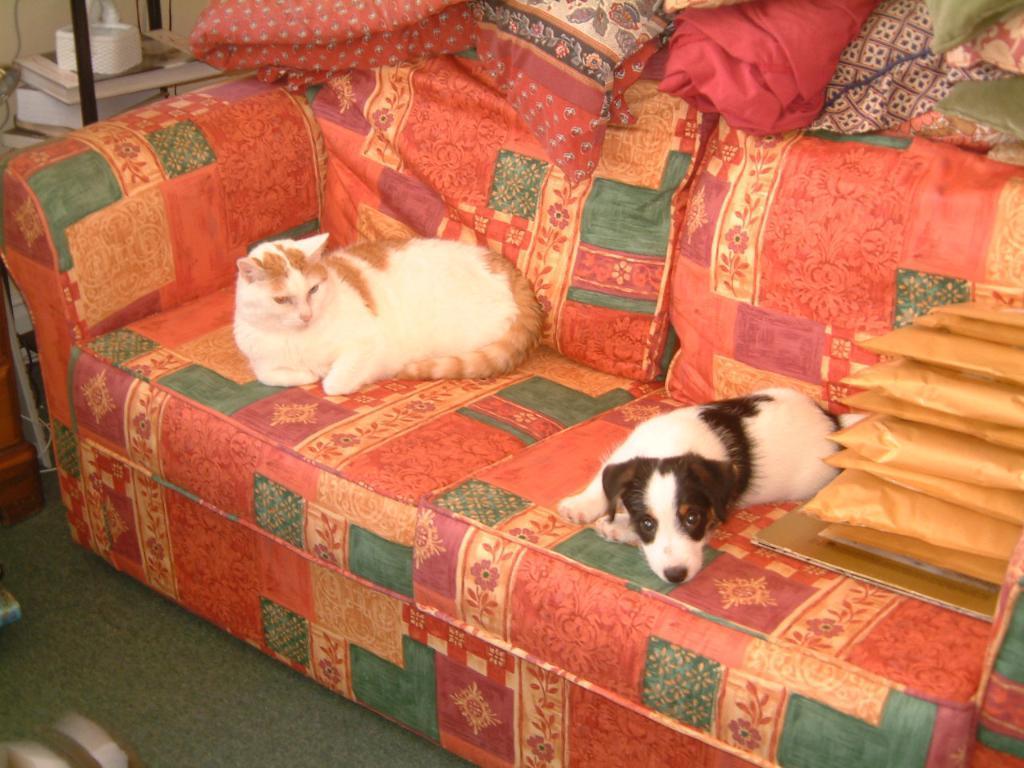Can you describe this image briefly? In this picture we can see a cat and a dog sitting on the sofa. We can see objects. In the bottom left corner of the picture we can see the floor. 